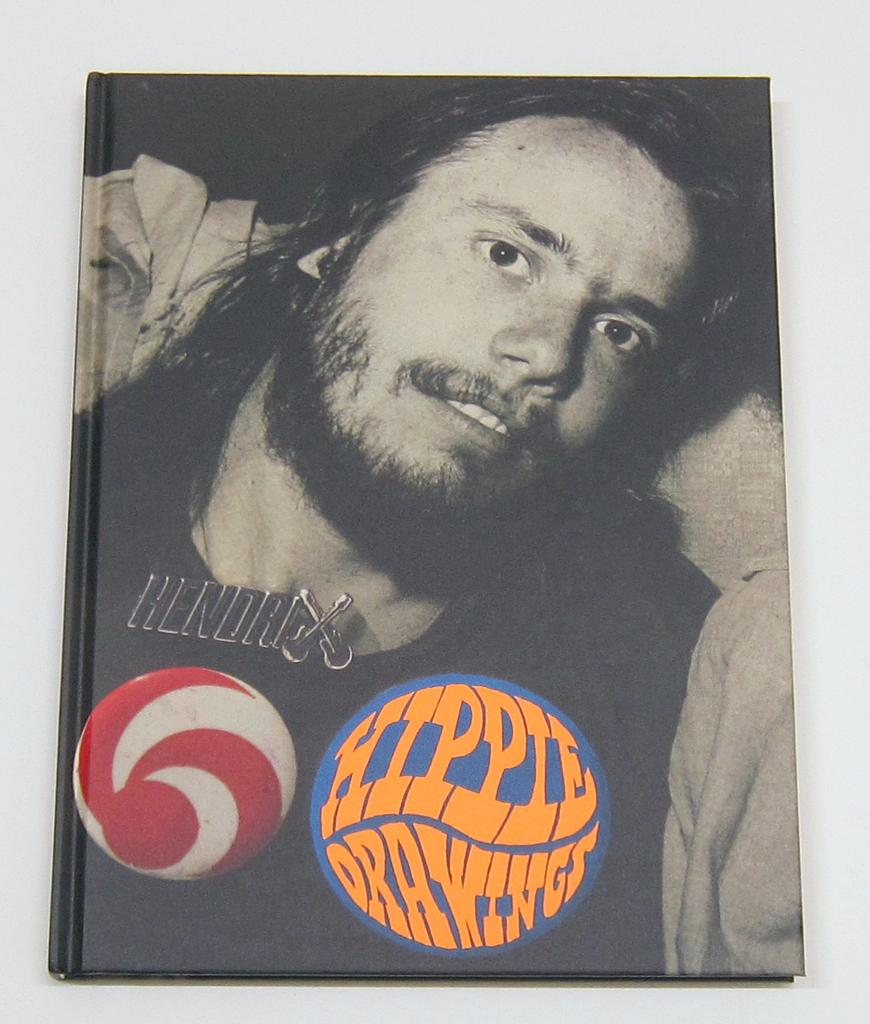Who is the main subject in the image? There is a man in the center of the image. What type of artwork is visible at the bottom side of the image? There are Richard Prince hippie drawings at the bottom side of the image. What type of animals can be seen at the zoo in the image? There is no zoo present in the image, so it is not possible to determine what, if any, animals might be seen. 